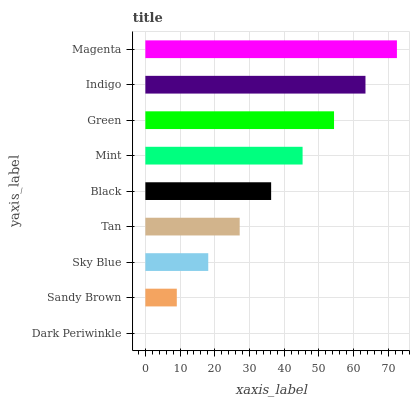Is Dark Periwinkle the minimum?
Answer yes or no. Yes. Is Magenta the maximum?
Answer yes or no. Yes. Is Sandy Brown the minimum?
Answer yes or no. No. Is Sandy Brown the maximum?
Answer yes or no. No. Is Sandy Brown greater than Dark Periwinkle?
Answer yes or no. Yes. Is Dark Periwinkle less than Sandy Brown?
Answer yes or no. Yes. Is Dark Periwinkle greater than Sandy Brown?
Answer yes or no. No. Is Sandy Brown less than Dark Periwinkle?
Answer yes or no. No. Is Black the high median?
Answer yes or no. Yes. Is Black the low median?
Answer yes or no. Yes. Is Sky Blue the high median?
Answer yes or no. No. Is Magenta the low median?
Answer yes or no. No. 